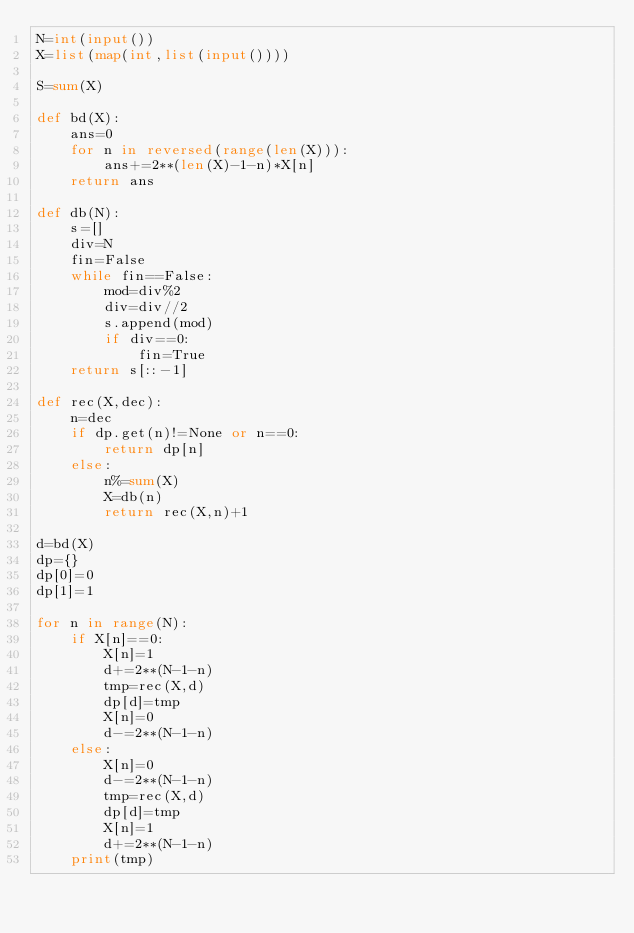Convert code to text. <code><loc_0><loc_0><loc_500><loc_500><_Python_>N=int(input())
X=list(map(int,list(input())))

S=sum(X)

def bd(X):
    ans=0
    for n in reversed(range(len(X))):
        ans+=2**(len(X)-1-n)*X[n]
    return ans

def db(N):
    s=[]
    div=N
    fin=False
    while fin==False:
        mod=div%2
        div=div//2
        s.append(mod)
        if div==0:
            fin=True
    return s[::-1]

def rec(X,dec):
    n=dec
    if dp.get(n)!=None or n==0:
        return dp[n]
    else:
        n%=sum(X)
        X=db(n)
        return rec(X,n)+1

d=bd(X)
dp={}
dp[0]=0
dp[1]=1

for n in range(N):
    if X[n]==0:
        X[n]=1
        d+=2**(N-1-n)
        tmp=rec(X,d)
        dp[d]=tmp
        X[n]=0
        d-=2**(N-1-n)
    else:
        X[n]=0
        d-=2**(N-1-n)
        tmp=rec(X,d)
        dp[d]=tmp
        X[n]=1
        d+=2**(N-1-n)
    print(tmp)</code> 